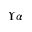Convert formula to latex. <formula><loc_0><loc_0><loc_500><loc_500>\Upsilon \alpha</formula> 